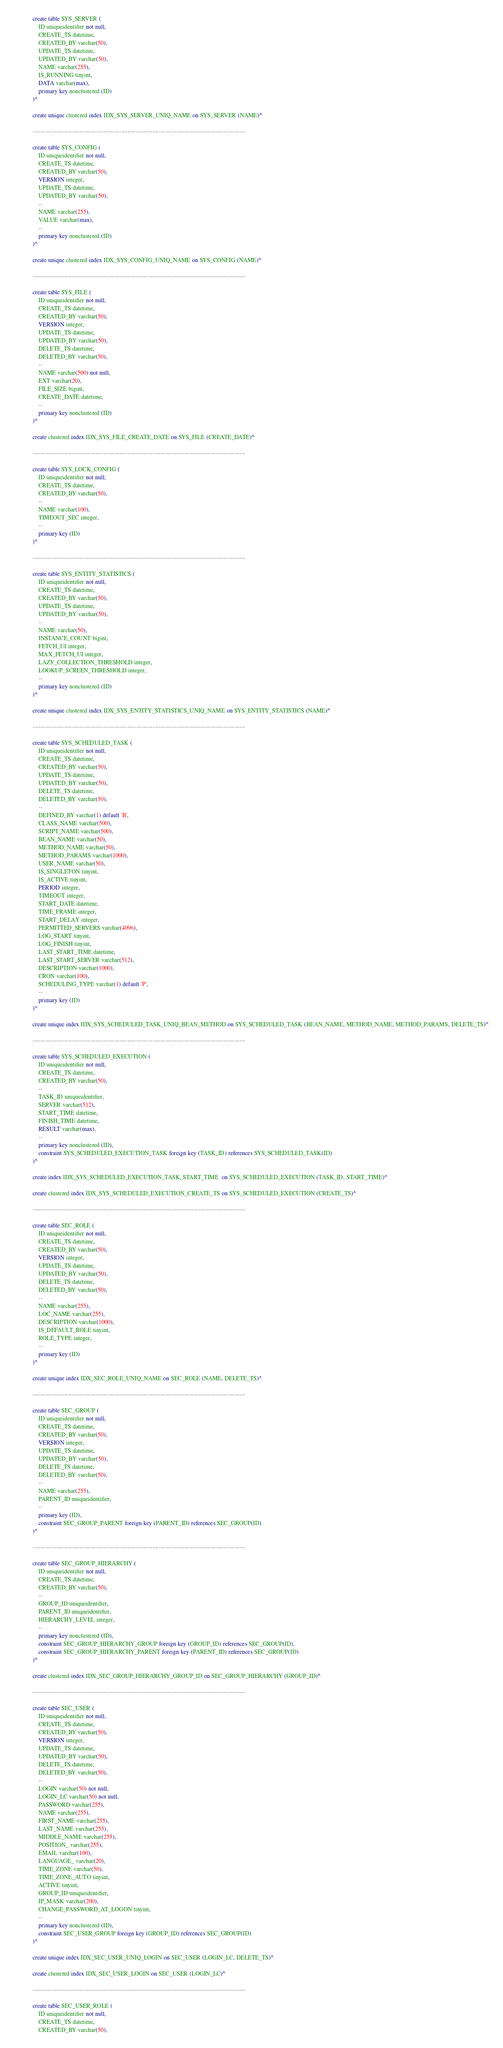Convert code to text. <code><loc_0><loc_0><loc_500><loc_500><_SQL_>
create table SYS_SERVER (
    ID uniqueidentifier not null,
    CREATE_TS datetime,
    CREATED_BY varchar(50),
    UPDATE_TS datetime,
    UPDATED_BY varchar(50),
    NAME varchar(255),
    IS_RUNNING tinyint,
    DATA varchar(max),
    primary key nonclustered (ID)
)^

create unique clustered index IDX_SYS_SERVER_UNIQ_NAME on SYS_SERVER (NAME)^

------------------------------------------------------------------------------------------------------------

create table SYS_CONFIG (
    ID uniqueidentifier not null,
    CREATE_TS datetime,
    CREATED_BY varchar(50),
    VERSION integer,
    UPDATE_TS datetime,
    UPDATED_BY varchar(50),
    --
    NAME varchar(255),
    VALUE varchar(max),
    --
    primary key nonclustered (ID)
)^

create unique clustered index IDX_SYS_CONFIG_UNIQ_NAME on SYS_CONFIG (NAME)^

------------------------------------------------------------------------------------------------------------

create table SYS_FILE (
    ID uniqueidentifier not null,
    CREATE_TS datetime,
    CREATED_BY varchar(50),
    VERSION integer,
    UPDATE_TS datetime,
    UPDATED_BY varchar(50),
    DELETE_TS datetime,
    DELETED_BY varchar(50),
    --
    NAME varchar(500) not null,
    EXT varchar(20),
    FILE_SIZE bigint,
    CREATE_DATE datetime,
    --
    primary key nonclustered (ID)
)^

create clustered index IDX_SYS_FILE_CREATE_DATE on SYS_FILE (CREATE_DATE)^

------------------------------------------------------------------------------------------------------------

create table SYS_LOCK_CONFIG (
    ID uniqueidentifier not null,
    CREATE_TS datetime,
    CREATED_BY varchar(50),
    --
    NAME varchar(100),
    TIMEOUT_SEC integer,
    --
    primary key (ID)
)^

------------------------------------------------------------------------------------------------------------

create table SYS_ENTITY_STATISTICS (
    ID uniqueidentifier not null,
    CREATE_TS datetime,
    CREATED_BY varchar(50),
    UPDATE_TS datetime,
    UPDATED_BY varchar(50),
    --
    NAME varchar(50),
    INSTANCE_COUNT bigint,
    FETCH_UI integer,
    MAX_FETCH_UI integer,
    LAZY_COLLECTION_THRESHOLD integer,
    LOOKUP_SCREEN_THRESHOLD integer,
    --
    primary key nonclustered (ID)
)^

create unique clustered index IDX_SYS_ENTITY_STATISTICS_UNIQ_NAME on SYS_ENTITY_STATISTICS (NAME)^

------------------------------------------------------------------------------------------------------------

create table SYS_SCHEDULED_TASK (
    ID uniqueidentifier not null,
    CREATE_TS datetime,
    CREATED_BY varchar(50),
    UPDATE_TS datetime,
    UPDATED_BY varchar(50),
    DELETE_TS datetime,
    DELETED_BY varchar(50),
    --
    DEFINED_BY varchar(1) default 'B',
    CLASS_NAME varchar(500),
    SCRIPT_NAME varchar(500),
    BEAN_NAME varchar(50),
    METHOD_NAME varchar(50),
    METHOD_PARAMS varchar(1000),
    USER_NAME varchar(50),
    IS_SINGLETON tinyint,
    IS_ACTIVE tinyint,
    PERIOD integer,
    TIMEOUT integer,
    START_DATE datetime,
    TIME_FRAME integer,
    START_DELAY integer,
    PERMITTED_SERVERS varchar(4096),
    LOG_START tinyint,
    LOG_FINISH tinyint,
    LAST_START_TIME datetime,
    LAST_START_SERVER varchar(512),
    DESCRIPTION varchar(1000),
    CRON varchar(100),
    SCHEDULING_TYPE varchar(1) default 'P',
    --
    primary key (ID)
)^

create unique index IDX_SYS_SCHEDULED_TASK_UNIQ_BEAN_METHOD on SYS_SCHEDULED_TASK (BEAN_NAME, METHOD_NAME, METHOD_PARAMS, DELETE_TS)^

------------------------------------------------------------------------------------------------------------

create table SYS_SCHEDULED_EXECUTION (
    ID uniqueidentifier not null,
    CREATE_TS datetime,
    CREATED_BY varchar(50),
    --
    TASK_ID uniqueidentifier,
    SERVER varchar(512),
    START_TIME datetime,
    FINISH_TIME datetime,
    RESULT varchar(max),
    --
    primary key nonclustered (ID),
    constraint SYS_SCHEDULED_EXECUTION_TASK foreign key (TASK_ID) references SYS_SCHEDULED_TASK(ID)
)^

create index IDX_SYS_SCHEDULED_EXECUTION_TASK_START_TIME  on SYS_SCHEDULED_EXECUTION (TASK_ID, START_TIME)^

create clustered index IDX_SYS_SCHEDULED_EXECUTION_CREATE_TS on SYS_SCHEDULED_EXECUTION (CREATE_TS)^

------------------------------------------------------------------------------------------------------------

create table SEC_ROLE (
    ID uniqueidentifier not null,
    CREATE_TS datetime,
    CREATED_BY varchar(50),
    VERSION integer,
    UPDATE_TS datetime,
    UPDATED_BY varchar(50),
    DELETE_TS datetime,
    DELETED_BY varchar(50),
    --
    NAME varchar(255),
    LOC_NAME varchar(255),
    DESCRIPTION varchar(1000),
    IS_DEFAULT_ROLE tinyint, 
    ROLE_TYPE integer,
    --
    primary key (ID)
)^

create unique index IDX_SEC_ROLE_UNIQ_NAME on SEC_ROLE (NAME, DELETE_TS)^

------------------------------------------------------------------------------------------------------------

create table SEC_GROUP (
    ID uniqueidentifier not null,
    CREATE_TS datetime,
    CREATED_BY varchar(50),
    VERSION integer,
    UPDATE_TS datetime,
    UPDATED_BY varchar(50),
    DELETE_TS datetime,
    DELETED_BY varchar(50),
    --
    NAME varchar(255),
    PARENT_ID uniqueidentifier,
    --
    primary key (ID),
    constraint SEC_GROUP_PARENT foreign key (PARENT_ID) references SEC_GROUP(ID)
)^

------------------------------------------------------------------------------------------------------------

create table SEC_GROUP_HIERARCHY (
    ID uniqueidentifier not null,
    CREATE_TS datetime,
    CREATED_BY varchar(50),
    --
    GROUP_ID uniqueidentifier,
    PARENT_ID uniqueidentifier,
    HIERARCHY_LEVEL integer,
    --
    primary key nonclustered (ID),
    constraint SEC_GROUP_HIERARCHY_GROUP foreign key (GROUP_ID) references SEC_GROUP(ID),
    constraint SEC_GROUP_HIERARCHY_PARENT foreign key (PARENT_ID) references SEC_GROUP(ID)
)^

create clustered index IDX_SEC_GROUP_HIERARCHY_GROUP_ID on SEC_GROUP_HIERARCHY (GROUP_ID)^

------------------------------------------------------------------------------------------------------------

create table SEC_USER (
    ID uniqueidentifier not null,
    CREATE_TS datetime,
    CREATED_BY varchar(50),
    VERSION integer,
    UPDATE_TS datetime,
    UPDATED_BY varchar(50),
    DELETE_TS datetime,
    DELETED_BY varchar(50),
    --
    LOGIN varchar(50) not null,
    LOGIN_LC varchar(50) not null,
    PASSWORD varchar(255),
    NAME varchar(255),
    FIRST_NAME varchar(255),
    LAST_NAME varchar(255),
    MIDDLE_NAME varchar(255),
    POSITION_ varchar(255),
    EMAIL varchar(100),
    LANGUAGE_ varchar(20),
    TIME_ZONE varchar(50),
    TIME_ZONE_AUTO tinyint,
    ACTIVE tinyint,
    GROUP_ID uniqueidentifier,
    IP_MASK varchar(200),
    CHANGE_PASSWORD_AT_LOGON tinyint,
    --
    primary key nonclustered (ID),
    constraint SEC_USER_GROUP foreign key (GROUP_ID) references SEC_GROUP(ID)
)^

create unique index IDX_SEC_USER_UNIQ_LOGIN on SEC_USER (LOGIN_LC, DELETE_TS)^

create clustered index IDX_SEC_USER_LOGIN on SEC_USER (LOGIN_LC)^

------------------------------------------------------------------------------------------------------------

create table SEC_USER_ROLE (
    ID uniqueidentifier not null,
    CREATE_TS datetime,
    CREATED_BY varchar(50),</code> 